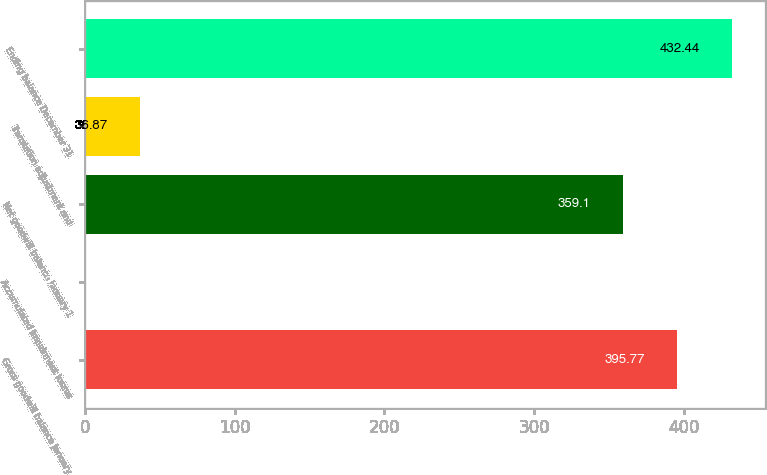Convert chart to OTSL. <chart><loc_0><loc_0><loc_500><loc_500><bar_chart><fcel>Gross goodwill balance January<fcel>Accumulated impairment losses<fcel>Net goodwill balance January 1<fcel>Translation adjustment and<fcel>Ending balance December 31<nl><fcel>395.77<fcel>0.2<fcel>359.1<fcel>36.87<fcel>432.44<nl></chart> 